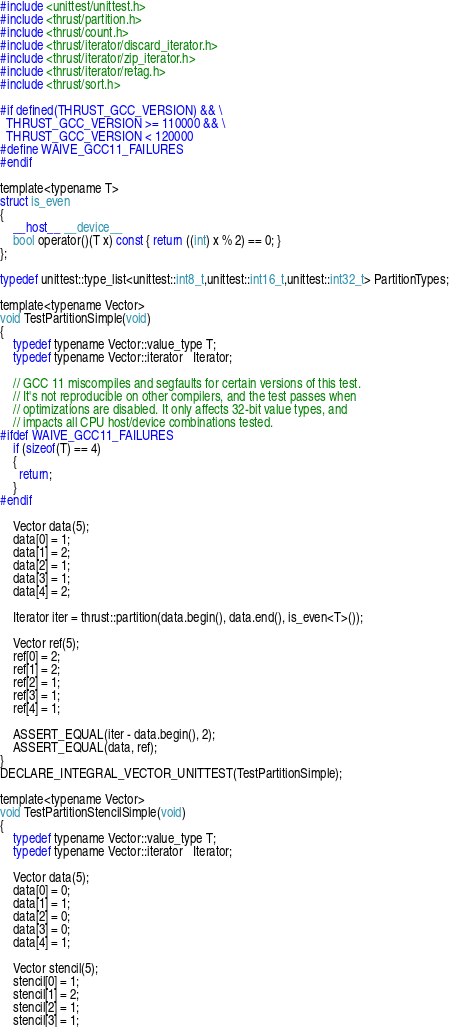<code> <loc_0><loc_0><loc_500><loc_500><_Cuda_>#include <unittest/unittest.h>
#include <thrust/partition.h>
#include <thrust/count.h>
#include <thrust/iterator/discard_iterator.h>
#include <thrust/iterator/zip_iterator.h>
#include <thrust/iterator/retag.h>
#include <thrust/sort.h>

#if defined(THRUST_GCC_VERSION) && \
  THRUST_GCC_VERSION >= 110000 && \
  THRUST_GCC_VERSION < 120000
#define WAIVE_GCC11_FAILURES
#endif

template<typename T>
struct is_even
{
    __host__ __device__
    bool operator()(T x) const { return ((int) x % 2) == 0; }
};

typedef unittest::type_list<unittest::int8_t,unittest::int16_t,unittest::int32_t> PartitionTypes;

template<typename Vector>
void TestPartitionSimple(void)
{
    typedef typename Vector::value_type T;
    typedef typename Vector::iterator   Iterator;

    // GCC 11 miscompiles and segfaults for certain versions of this test.
    // It's not reproducible on other compilers, and the test passes when
    // optimizations are disabled. It only affects 32-bit value types, and
    // impacts all CPU host/device combinations tested.
#ifdef WAIVE_GCC11_FAILURES
    if (sizeof(T) == 4)
    {
      return;
    }
#endif

    Vector data(5);
    data[0] = 1; 
    data[1] = 2; 
    data[2] = 1;
    data[3] = 1; 
    data[4] = 2; 

    Iterator iter = thrust::partition(data.begin(), data.end(), is_even<T>());

    Vector ref(5);
    ref[0] = 2;
    ref[1] = 2;
    ref[2] = 1;
    ref[3] = 1;
    ref[4] = 1;

    ASSERT_EQUAL(iter - data.begin(), 2);
    ASSERT_EQUAL(data, ref);
}
DECLARE_INTEGRAL_VECTOR_UNITTEST(TestPartitionSimple);

template<typename Vector>
void TestPartitionStencilSimple(void)
{
    typedef typename Vector::value_type T;
    typedef typename Vector::iterator   Iterator;

    Vector data(5);
    data[0] = 0;
    data[1] = 1;
    data[2] = 0;
    data[3] = 0;
    data[4] = 1;

    Vector stencil(5);
    stencil[0] = 1; 
    stencil[1] = 2; 
    stencil[2] = 1;
    stencil[3] = 1; </code> 